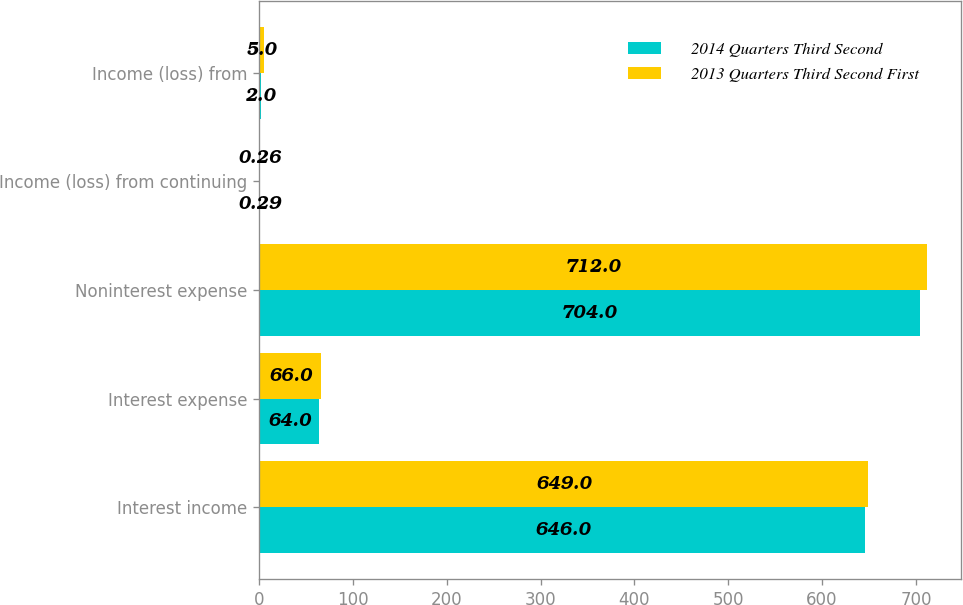Convert chart to OTSL. <chart><loc_0><loc_0><loc_500><loc_500><stacked_bar_chart><ecel><fcel>Interest income<fcel>Interest expense<fcel>Noninterest expense<fcel>Income (loss) from continuing<fcel>Income (loss) from<nl><fcel>2014 Quarters Third Second<fcel>646<fcel>64<fcel>704<fcel>0.29<fcel>2<nl><fcel>2013 Quarters Third Second First<fcel>649<fcel>66<fcel>712<fcel>0.26<fcel>5<nl></chart> 